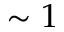<formula> <loc_0><loc_0><loc_500><loc_500>\sim 1</formula> 